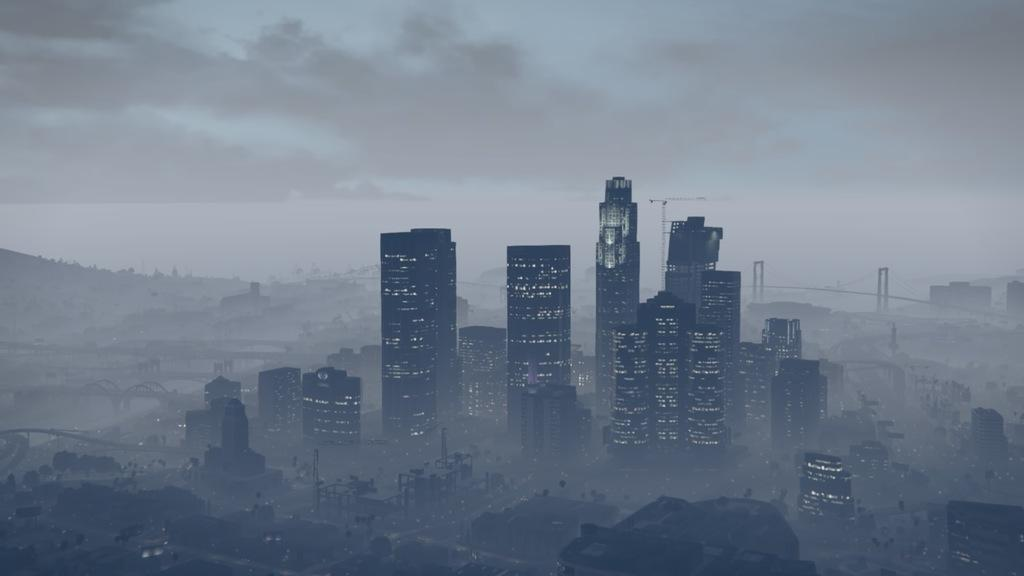What type of structures can be seen in the image? There are buildings and bridges in the image. What natural feature is visible in the image? There are mountains in the image. What type of brass plate can be seen on the side of the mountain in the image? There is no brass plate present on the side of the mountain in the image. What song is being played by the buildings in the image? The buildings in the image are not playing any song. 